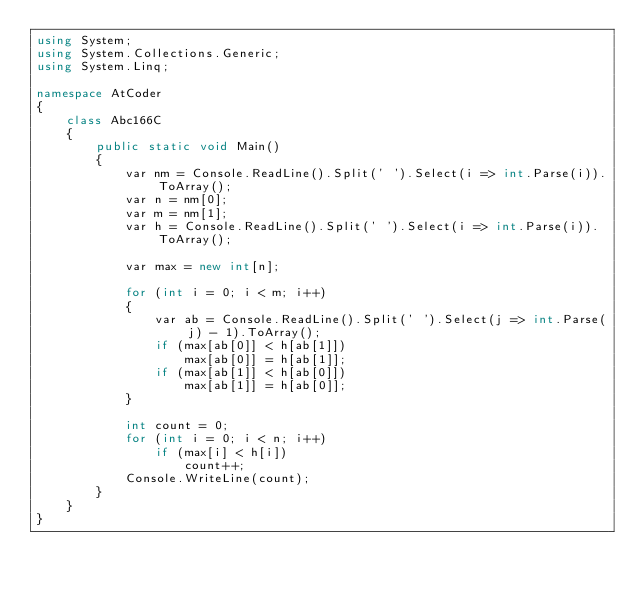Convert code to text. <code><loc_0><loc_0><loc_500><loc_500><_C#_>using System;
using System.Collections.Generic;
using System.Linq;

namespace AtCoder
{
    class Abc166C
    {
        public static void Main()
        {
            var nm = Console.ReadLine().Split(' ').Select(i => int.Parse(i)).ToArray();
            var n = nm[0];
            var m = nm[1];
            var h = Console.ReadLine().Split(' ').Select(i => int.Parse(i)).ToArray();

            var max = new int[n];

            for (int i = 0; i < m; i++)
            {
                var ab = Console.ReadLine().Split(' ').Select(j => int.Parse(j) - 1).ToArray();
                if (max[ab[0]] < h[ab[1]])
                    max[ab[0]] = h[ab[1]];
                if (max[ab[1]] < h[ab[0]])
                    max[ab[1]] = h[ab[0]];
            }

            int count = 0;
            for (int i = 0; i < n; i++)
                if (max[i] < h[i])
                    count++;
            Console.WriteLine(count);
        }
    }
}
</code> 